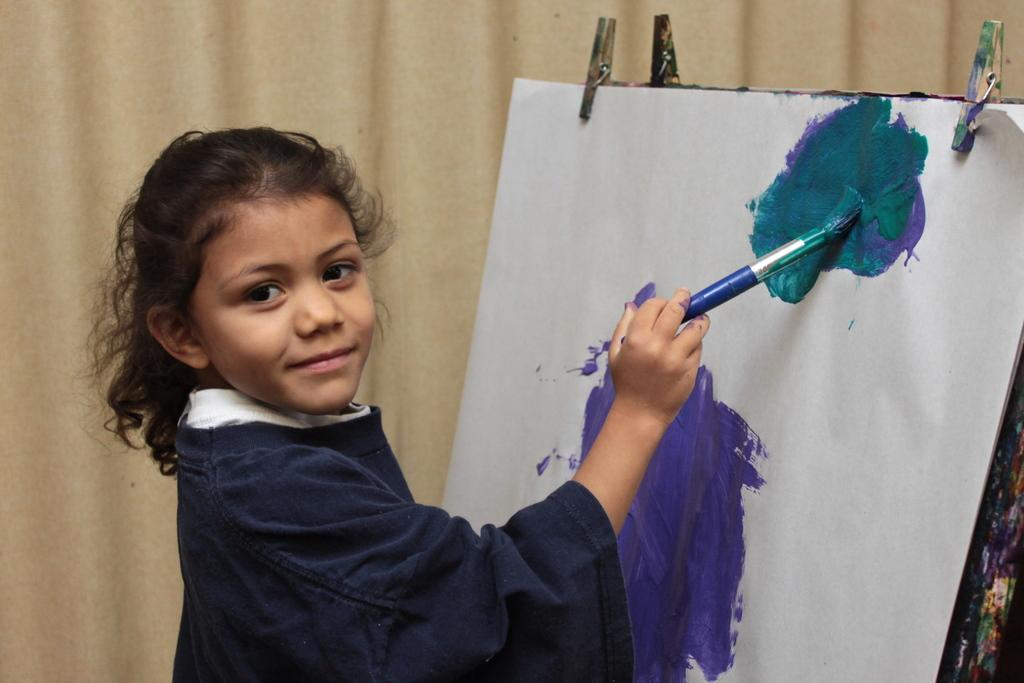Who is the main subject in the foreground of the image? There is a girl in the foreground of the image. What is the girl wearing? The girl is wearing a blue dress. What activity is the girl engaged in? The girl is painting on a painting board. What can be seen in the background of the image? There is a cream curtain in the background of the image. What is the girl's father doing in the image? There is no mention of a father or any other person in the image besides the girl. What is the girl's tendency to use yarn in her artwork? There is no yarn present in the image, and no information about the girl's tendencies in her artwork. 